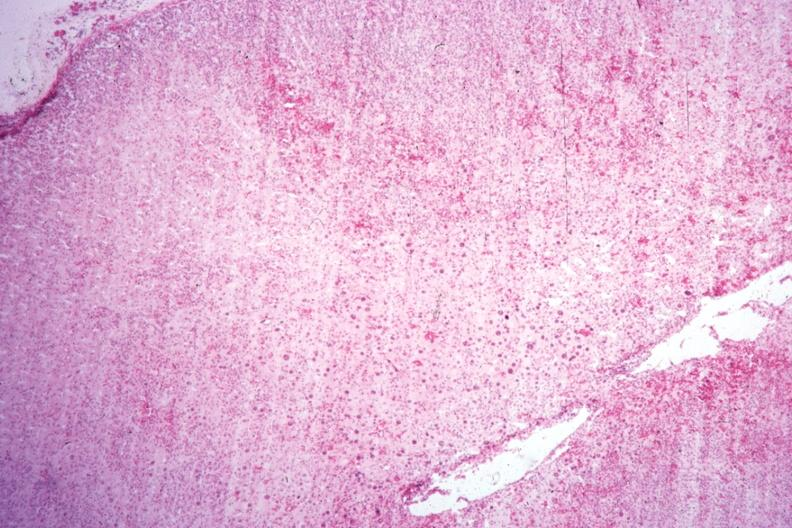does this typical lesion show localization of cytomegaly well shown?
Answer the question using a single word or phrase. No 